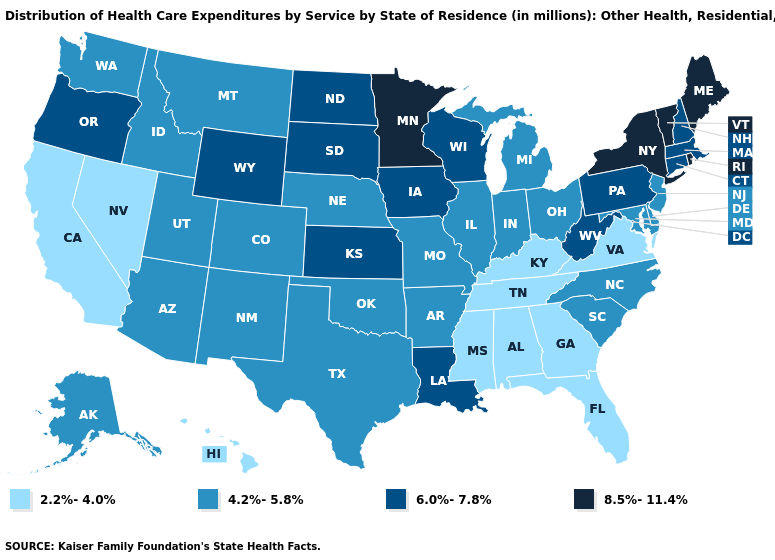Does Massachusetts have the highest value in the Northeast?
Be succinct. No. What is the value of Maine?
Quick response, please. 8.5%-11.4%. Name the states that have a value in the range 4.2%-5.8%?
Give a very brief answer. Alaska, Arizona, Arkansas, Colorado, Delaware, Idaho, Illinois, Indiana, Maryland, Michigan, Missouri, Montana, Nebraska, New Jersey, New Mexico, North Carolina, Ohio, Oklahoma, South Carolina, Texas, Utah, Washington. What is the value of Florida?
Keep it brief. 2.2%-4.0%. Which states have the highest value in the USA?
Keep it brief. Maine, Minnesota, New York, Rhode Island, Vermont. What is the value of Ohio?
Keep it brief. 4.2%-5.8%. Name the states that have a value in the range 2.2%-4.0%?
Concise answer only. Alabama, California, Florida, Georgia, Hawaii, Kentucky, Mississippi, Nevada, Tennessee, Virginia. Does Missouri have a lower value than Vermont?
Quick response, please. Yes. Does Kansas have the lowest value in the MidWest?
Keep it brief. No. Does Massachusetts have a lower value than South Carolina?
Quick response, please. No. Name the states that have a value in the range 6.0%-7.8%?
Be succinct. Connecticut, Iowa, Kansas, Louisiana, Massachusetts, New Hampshire, North Dakota, Oregon, Pennsylvania, South Dakota, West Virginia, Wisconsin, Wyoming. Which states have the lowest value in the Northeast?
Quick response, please. New Jersey. Name the states that have a value in the range 8.5%-11.4%?
Answer briefly. Maine, Minnesota, New York, Rhode Island, Vermont. What is the value of Minnesota?
Short answer required. 8.5%-11.4%. What is the lowest value in the West?
Answer briefly. 2.2%-4.0%. 